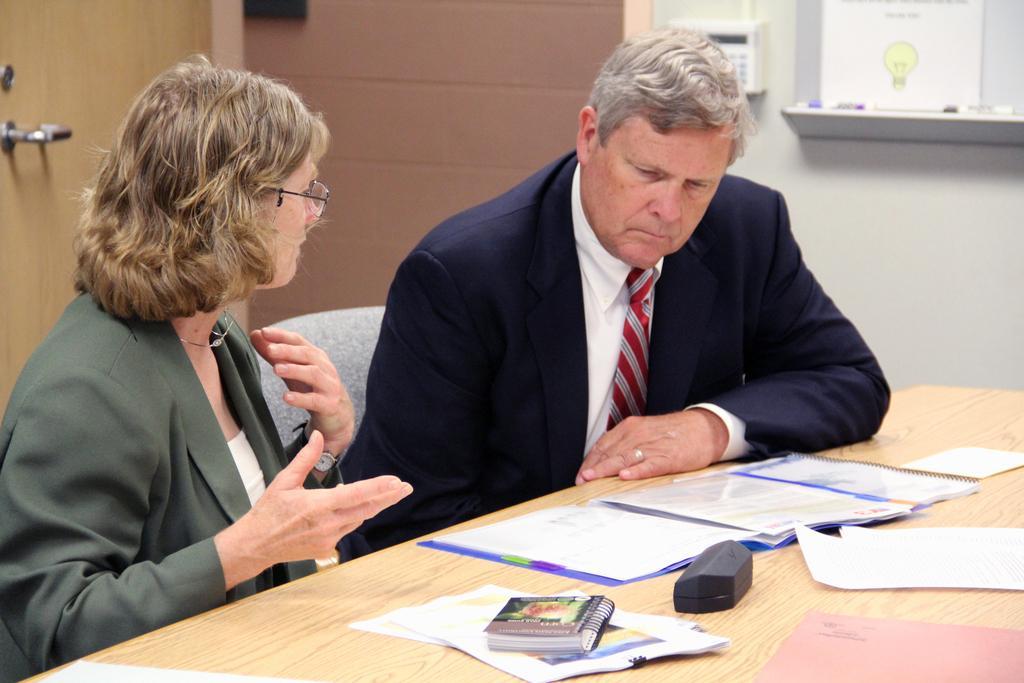In one or two sentences, can you explain what this image depicts? In this picture, we see the man and the women are sitting on the chairs. In front of them, we see a table on which files, papers, book and a black color box are placed. Behind them, we see a door and a wall in white and brown color. On the right side, we see a telephone and a board or poster in white color is pasted. 